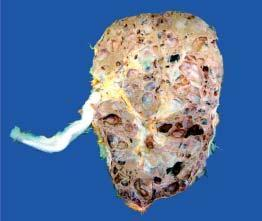re the congophilic areas not communicating with the pelvicalyceal system?
Answer the question using a single word or phrase. No 